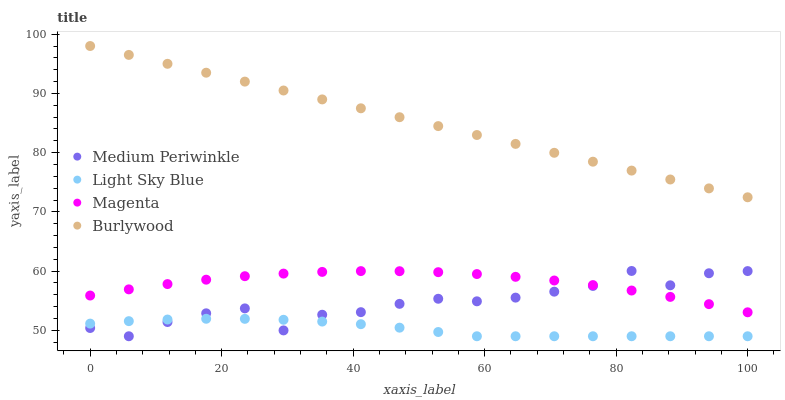Does Light Sky Blue have the minimum area under the curve?
Answer yes or no. Yes. Does Burlywood have the maximum area under the curve?
Answer yes or no. Yes. Does Magenta have the minimum area under the curve?
Answer yes or no. No. Does Magenta have the maximum area under the curve?
Answer yes or no. No. Is Burlywood the smoothest?
Answer yes or no. Yes. Is Medium Periwinkle the roughest?
Answer yes or no. Yes. Is Magenta the smoothest?
Answer yes or no. No. Is Magenta the roughest?
Answer yes or no. No. Does Light Sky Blue have the lowest value?
Answer yes or no. Yes. Does Magenta have the lowest value?
Answer yes or no. No. Does Burlywood have the highest value?
Answer yes or no. Yes. Does Magenta have the highest value?
Answer yes or no. No. Is Light Sky Blue less than Magenta?
Answer yes or no. Yes. Is Burlywood greater than Light Sky Blue?
Answer yes or no. Yes. Does Light Sky Blue intersect Medium Periwinkle?
Answer yes or no. Yes. Is Light Sky Blue less than Medium Periwinkle?
Answer yes or no. No. Is Light Sky Blue greater than Medium Periwinkle?
Answer yes or no. No. Does Light Sky Blue intersect Magenta?
Answer yes or no. No. 